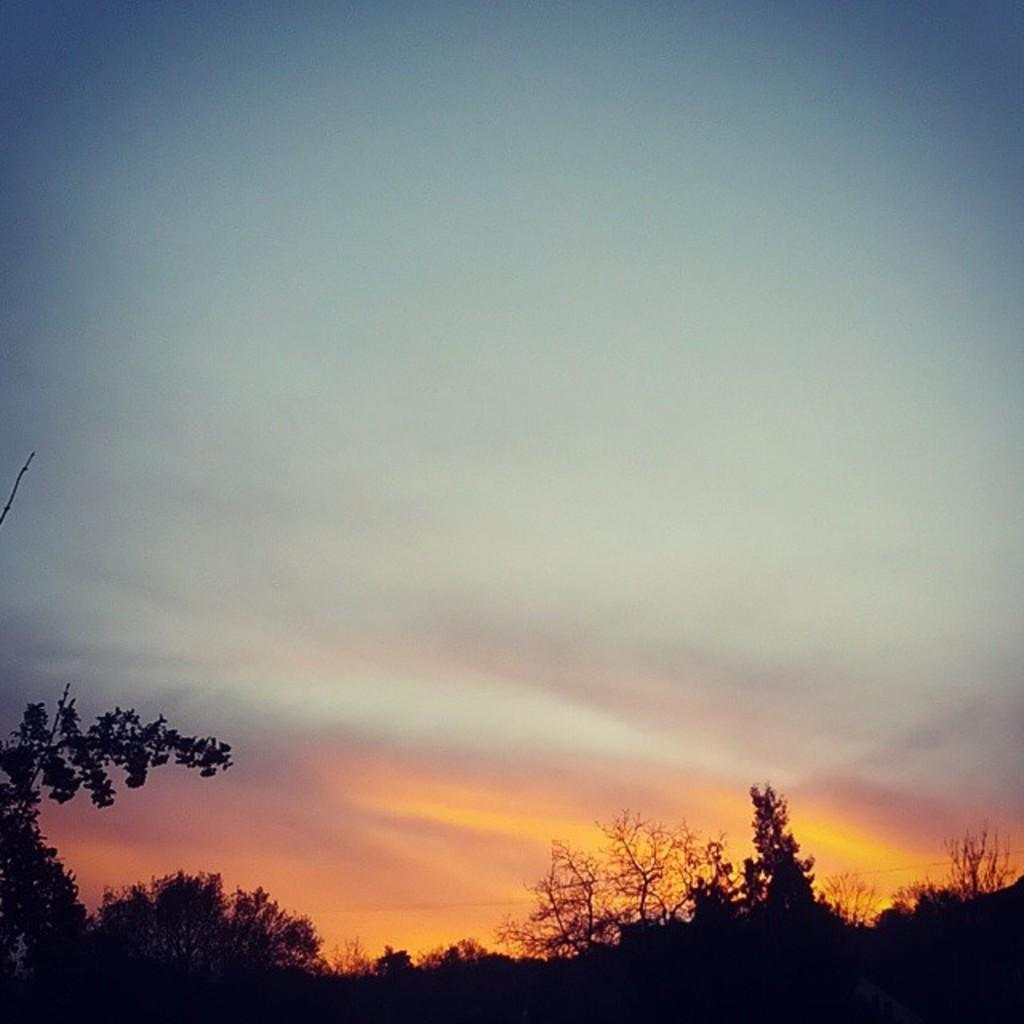Where was the image taken? The image is taken outdoors. What can be seen in the sky in the image? There is a sky with clouds in the image, and the sun is visible. What type of vegetation is present at the bottom of the image? There are trees and plants at the bottom of the image. What type of brush is being used by the maid in the image? There is no maid or brush present in the image. What type of trade is being conducted in the image? There is no trade or indication of any economic activity in the image. 